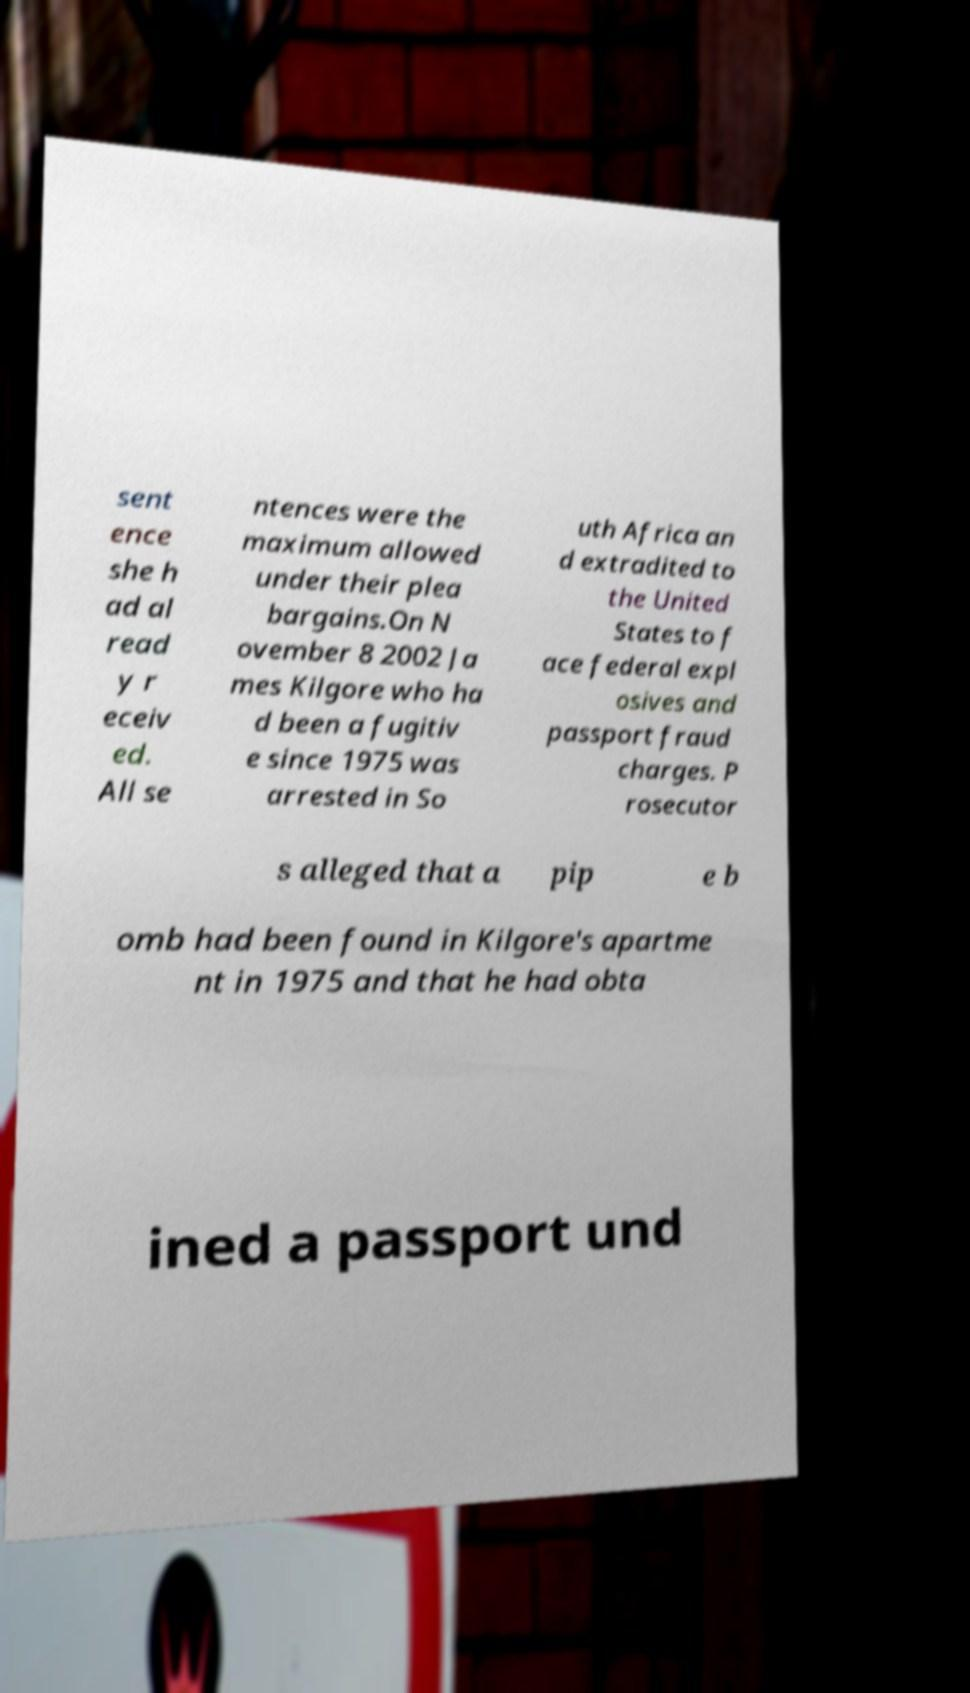Can you read and provide the text displayed in the image?This photo seems to have some interesting text. Can you extract and type it out for me? sent ence she h ad al read y r eceiv ed. All se ntences were the maximum allowed under their plea bargains.On N ovember 8 2002 Ja mes Kilgore who ha d been a fugitiv e since 1975 was arrested in So uth Africa an d extradited to the United States to f ace federal expl osives and passport fraud charges. P rosecutor s alleged that a pip e b omb had been found in Kilgore's apartme nt in 1975 and that he had obta ined a passport und 